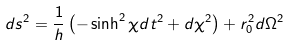<formula> <loc_0><loc_0><loc_500><loc_500>d s ^ { 2 } = \frac { 1 } { h } \left ( - \sinh ^ { 2 } \chi d t ^ { 2 } + d \chi ^ { 2 } \right ) + r _ { 0 } ^ { 2 } d \Omega ^ { 2 }</formula> 